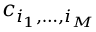Convert formula to latex. <formula><loc_0><loc_0><loc_500><loc_500>c _ { i _ { 1 } , \dots , i _ { M } }</formula> 